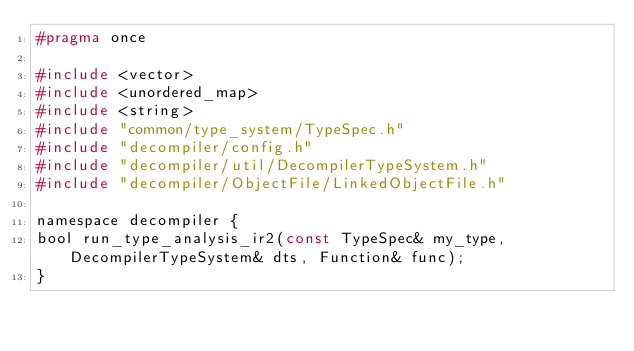<code> <loc_0><loc_0><loc_500><loc_500><_C_>#pragma once

#include <vector>
#include <unordered_map>
#include <string>
#include "common/type_system/TypeSpec.h"
#include "decompiler/config.h"
#include "decompiler/util/DecompilerTypeSystem.h"
#include "decompiler/ObjectFile/LinkedObjectFile.h"

namespace decompiler {
bool run_type_analysis_ir2(const TypeSpec& my_type, DecompilerTypeSystem& dts, Function& func);
}</code> 